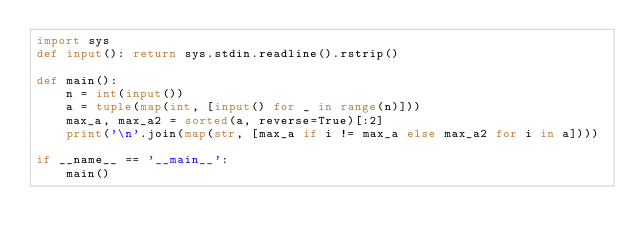<code> <loc_0><loc_0><loc_500><loc_500><_Python_>import sys
def input(): return sys.stdin.readline().rstrip()

def main():
    n = int(input())
    a = tuple(map(int, [input() for _ in range(n)]))
    max_a, max_a2 = sorted(a, reverse=True)[:2]
    print('\n'.join(map(str, [max_a if i != max_a else max_a2 for i in a])))

if __name__ == '__main__':
    main()
</code> 